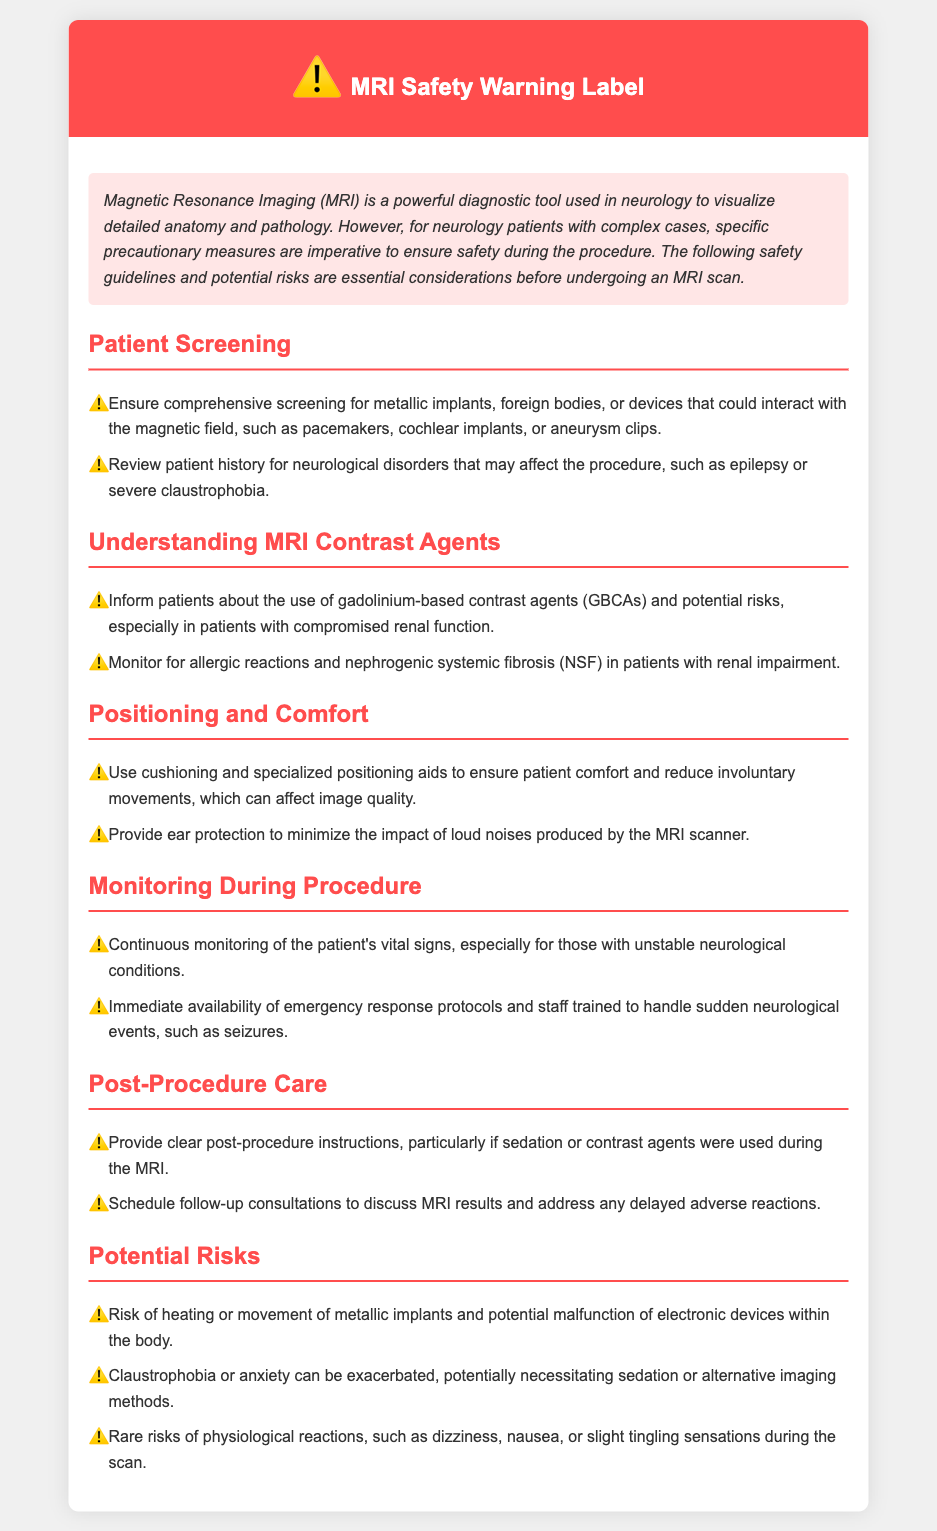What is the main purpose of the document? The document serves as a warning label outlining precautionary measures and safety guidelines regarding MRI procedures for neurology patients.
Answer: MRI Safety Warning Label What should be screened for before the MRI? The document states that a comprehensive screening for metallic implants, foreign bodies, or devices that could interact with the magnetic field should be ensured.
Answer: Metallic implants What is a potential risk of gadolinium-based contrast agents? The document mentions that a potential risk is nephrogenic systemic fibrosis (NSF) in patients with renal impairment.
Answer: Nephrogenic systemic fibrosis What is recommended for patients with severe claustrophobia? The document highlights that such patients may need alternative imaging methods due to exacerbated anxiety during the scan.
Answer: Alternative imaging methods How should a patient's comfort be ensured during the MRI? The document suggests using cushioning and specialized positioning aids to promote comfort and reduce movements.
Answer: Cushioning and positioning aids What should be monitored during the MRI procedure? Continuous monitoring of the patient's vital signs is advised, especially for those with unstable neurological conditions.
Answer: Vital signs What should be provided post-procedure, especially if sedation was used? The document states that clear post-procedure instructions should be provided.
Answer: Clear post-procedure instructions What type of psychological issue may arise during the MRI scan? The document notes that claustrophobia or anxiety can be exacerbated during the procedure.
Answer: Claustrophobia How often should follow-up consultations be scheduled? The document implies that follow-up consultations should be scheduled to discuss MRI results and address any reactions.
Answer: After the MRI results 